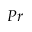Convert formula to latex. <formula><loc_0><loc_0><loc_500><loc_500>P r</formula> 